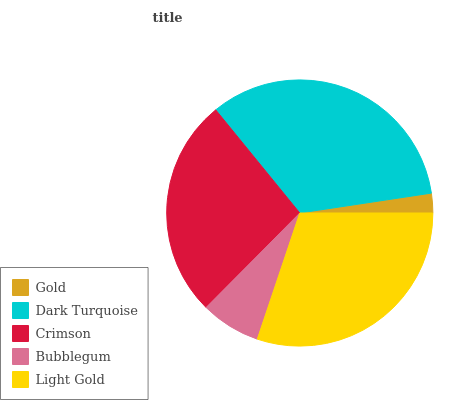Is Gold the minimum?
Answer yes or no. Yes. Is Dark Turquoise the maximum?
Answer yes or no. Yes. Is Crimson the minimum?
Answer yes or no. No. Is Crimson the maximum?
Answer yes or no. No. Is Dark Turquoise greater than Crimson?
Answer yes or no. Yes. Is Crimson less than Dark Turquoise?
Answer yes or no. Yes. Is Crimson greater than Dark Turquoise?
Answer yes or no. No. Is Dark Turquoise less than Crimson?
Answer yes or no. No. Is Crimson the high median?
Answer yes or no. Yes. Is Crimson the low median?
Answer yes or no. Yes. Is Light Gold the high median?
Answer yes or no. No. Is Gold the low median?
Answer yes or no. No. 